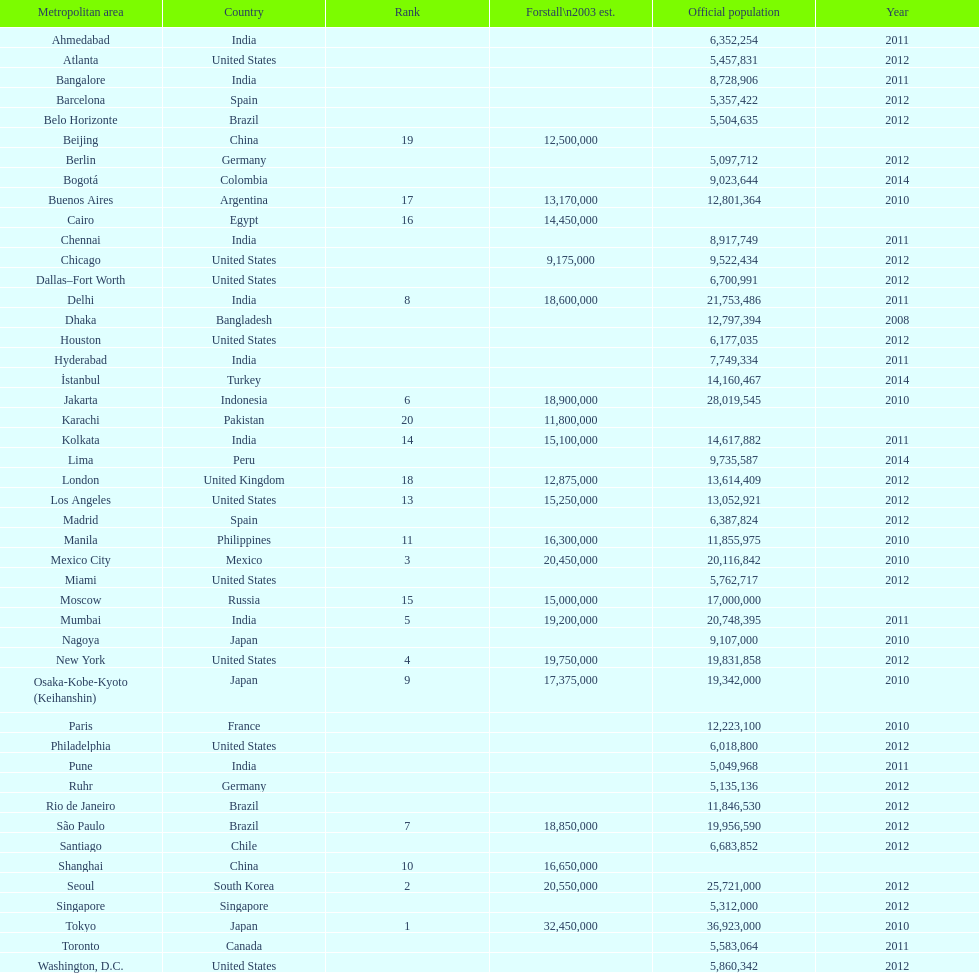How many cities are in the united states? 9. 